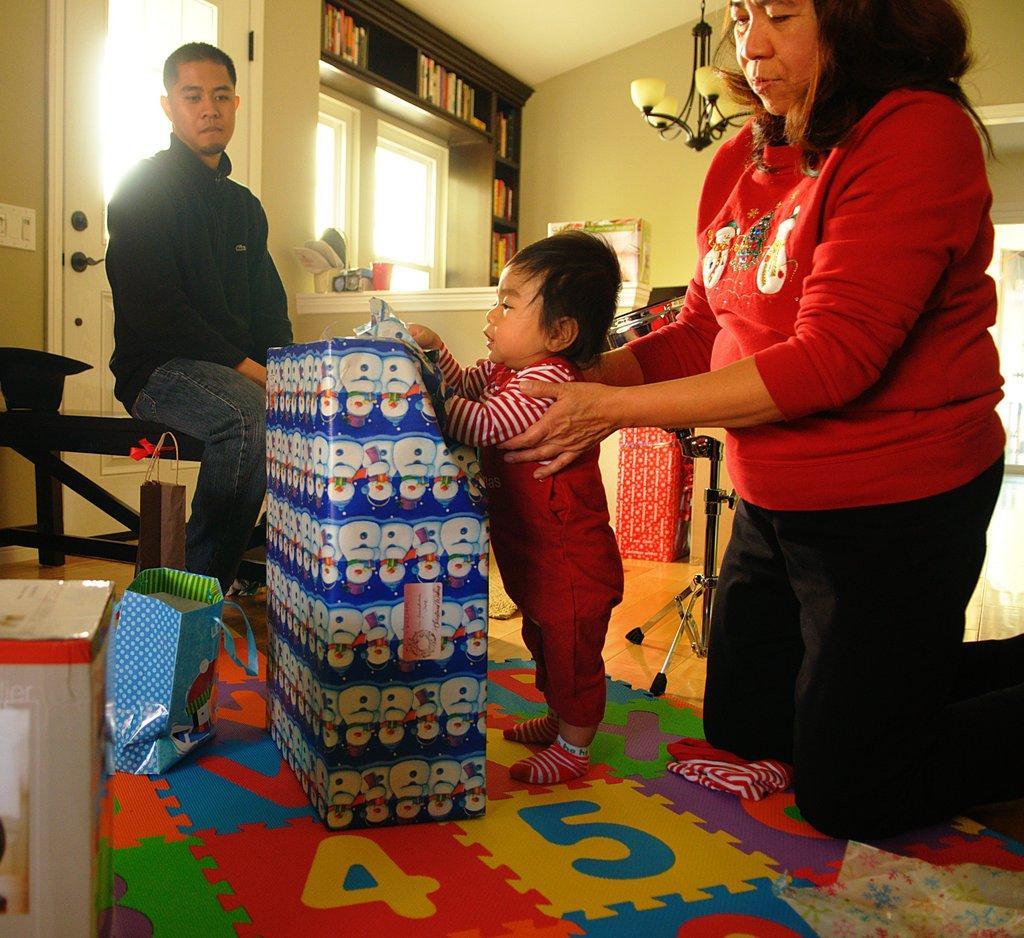Can you describe this image briefly? In this picture there is a kid standing in front of a gift wrapped box and there is a woman holding the kid from his back and there is a person sitting on a bench in the left corner and there is a door behind him and there is a bookshelf and some other objects in the background. 